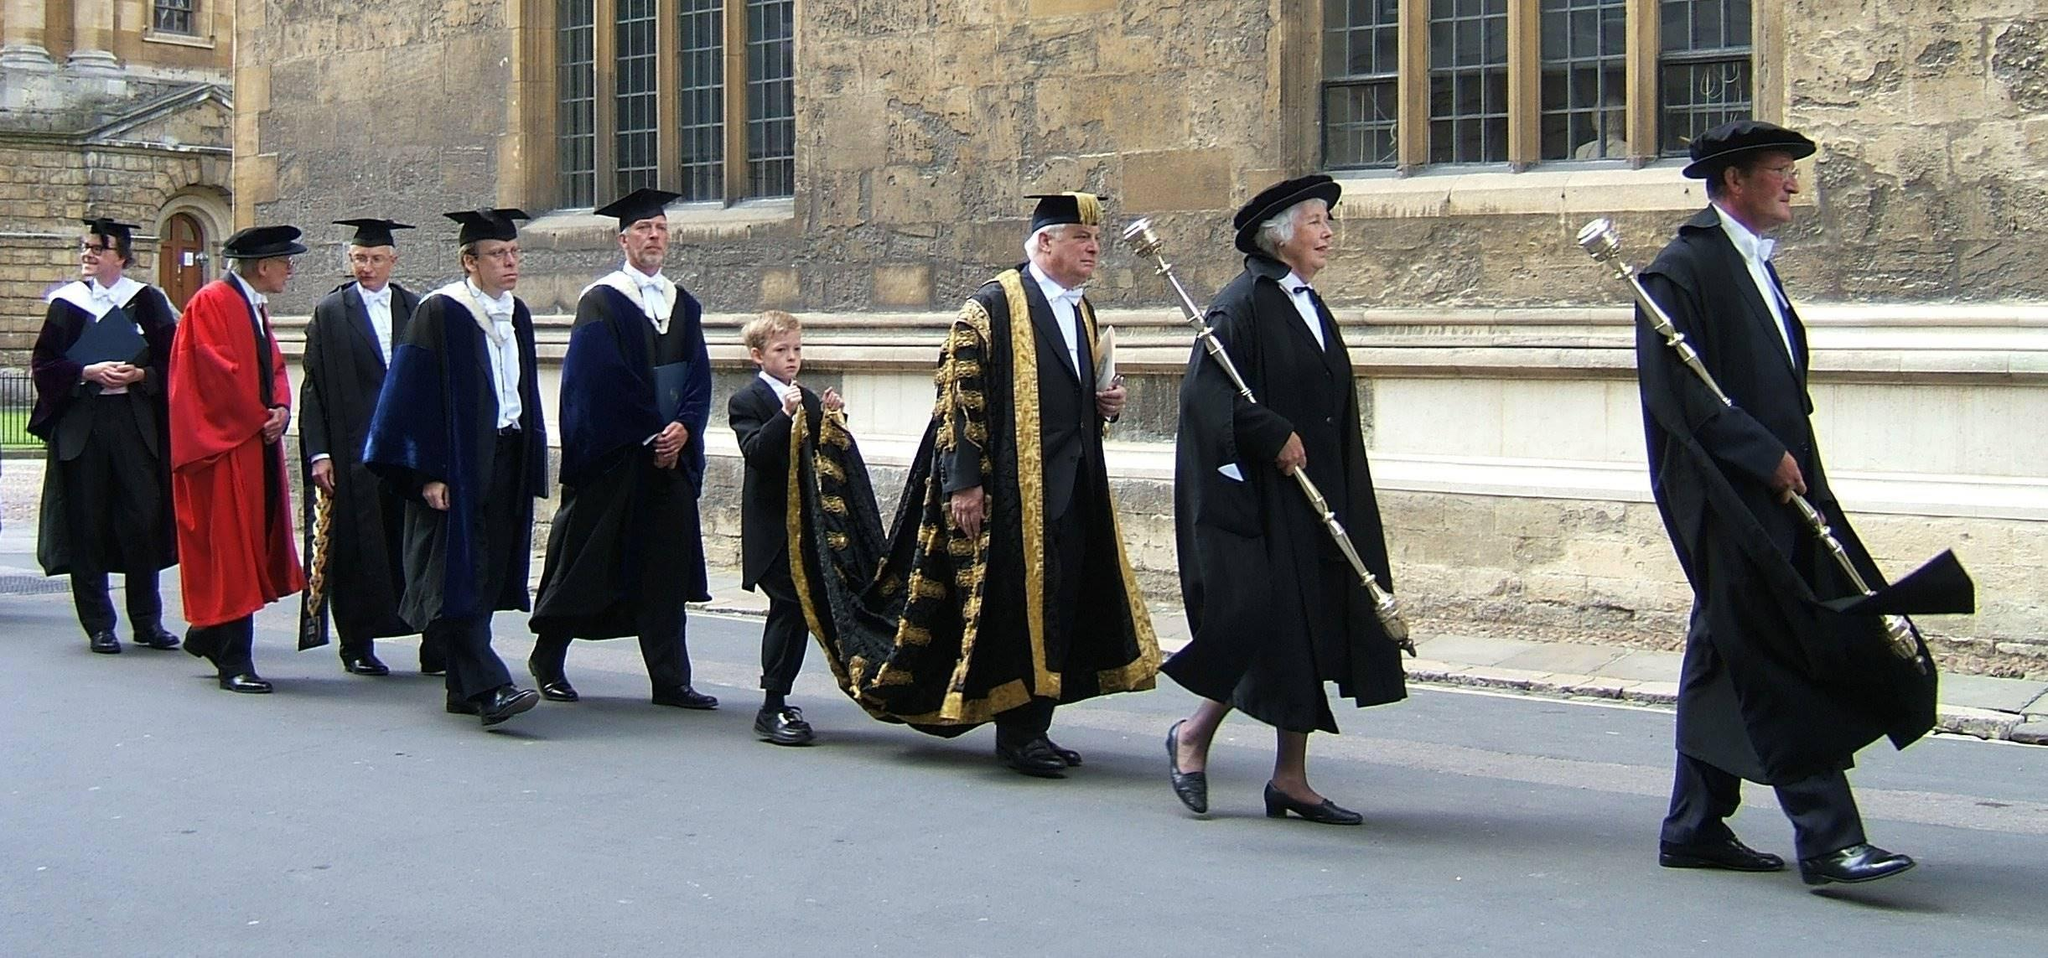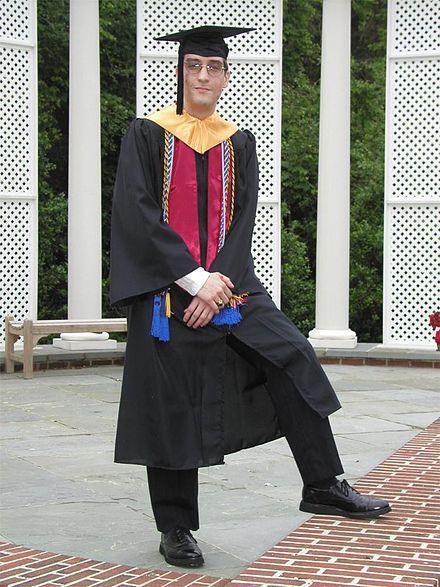The first image is the image on the left, the second image is the image on the right. Considering the images on both sides, is "An image shows exactly one male and one female graduate, wearing matching robes." valid? Answer yes or no. No. The first image is the image on the left, the second image is the image on the right. Analyze the images presented: Is the assertion "There is exactly three graduation students in the right image." valid? Answer yes or no. No. 